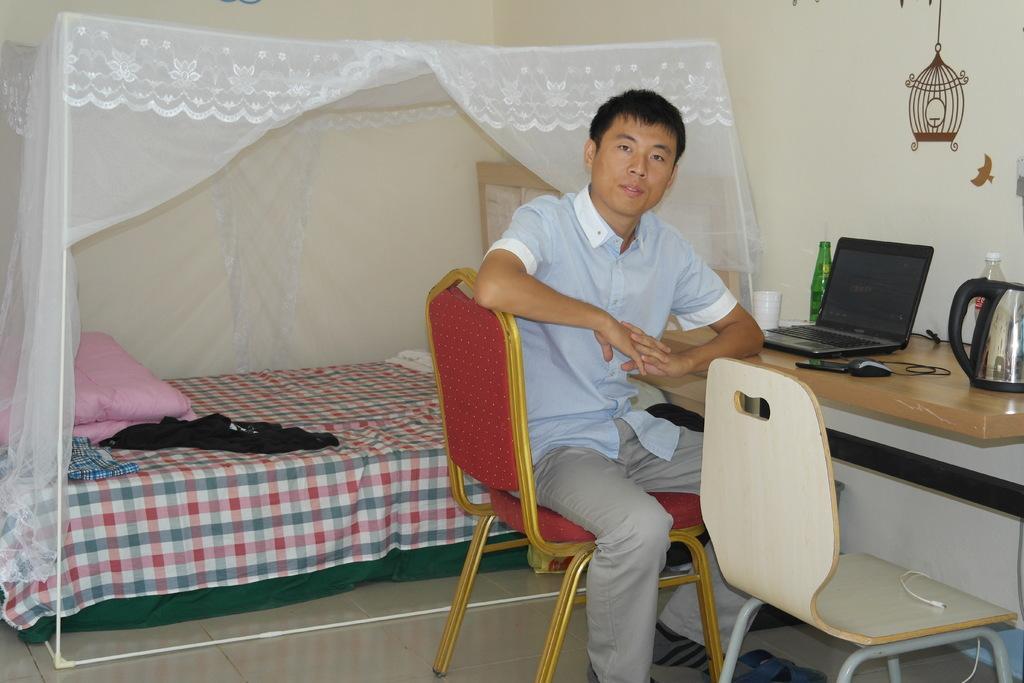Describe this image in one or two sentences. In this image I can see the person sitting on the chair. In front of him there is a laptop,cup,bottle,flask on the table. At the back of him there is a bed with the net. On that bed there are some clothes and the blanket. 